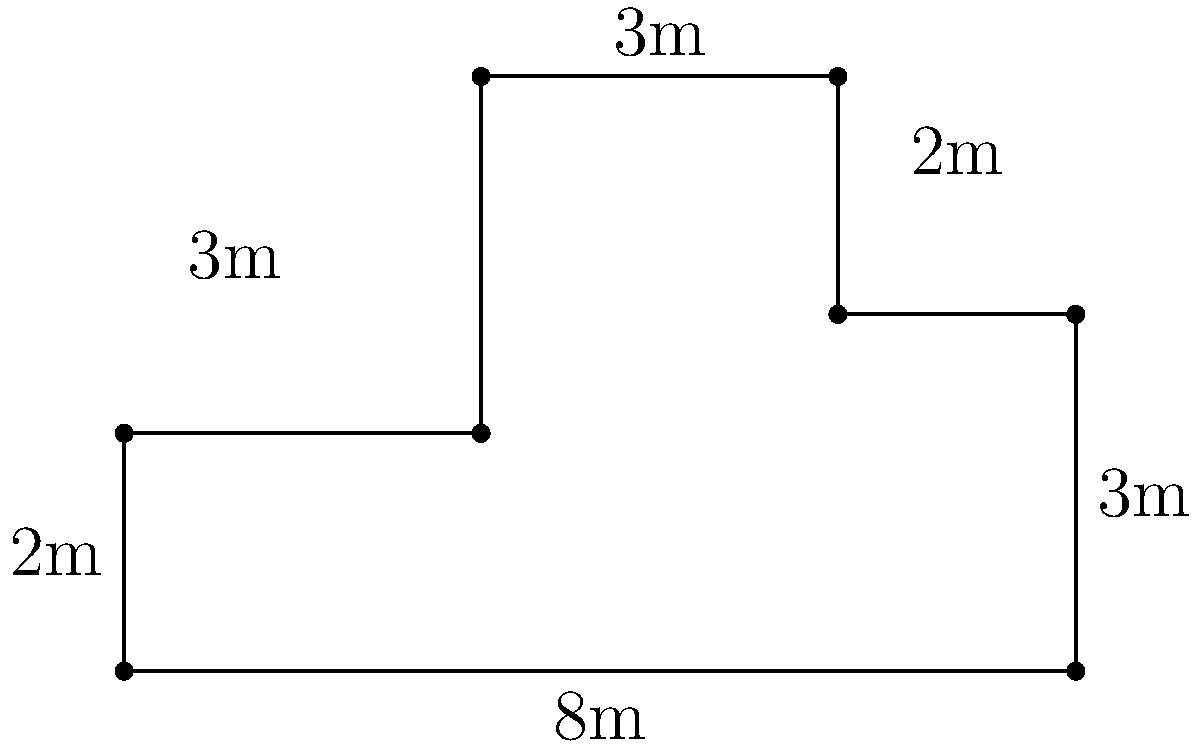You're planning a low-cost office celebration and need to calculate the amount of decorative ribbon required to line the perimeter of your irregularly shaped office space. Given the floor plan above, what is the total perimeter of the office in meters? To calculate the perimeter of the irregularly shaped office, we need to sum up all the side lengths:

1. Bottom side: $8$ m
2. Right side (bottom part): $3$ m
3. Right side (top part): $2$ m
4. Top side (right part): $3$ m
5. Top side (left part): $3$ m
6. Left side (top part): $3$ m
7. Left side (bottom part): $2$ m

Now, let's add all these lengths:

$$\text{Perimeter} = 8 + 3 + 2 + 3 + 3 + 3 + 2 = 24\text{ m}$$

Therefore, the total perimeter of the office is 24 meters.
Answer: 24 m 